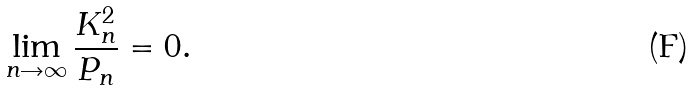Convert formula to latex. <formula><loc_0><loc_0><loc_500><loc_500>\lim _ { n \rightarrow \infty } \frac { K ^ { 2 } _ { n } } { P _ { n } } = 0 .</formula> 